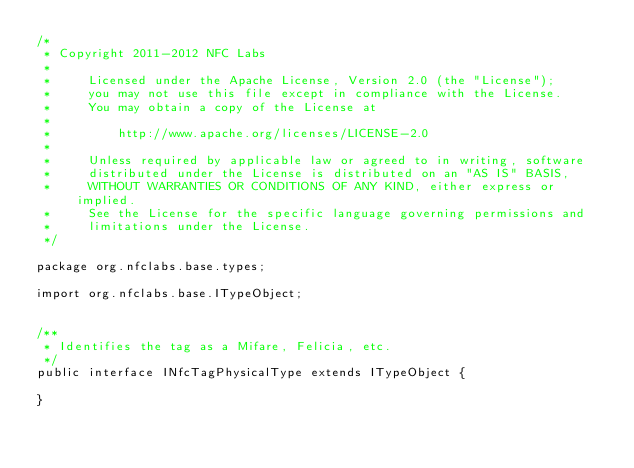Convert code to text. <code><loc_0><loc_0><loc_500><loc_500><_Java_>/*
 * Copyright 2011-2012 NFC Labs
 *
 *     Licensed under the Apache License, Version 2.0 (the "License");
 *     you may not use this file except in compliance with the License.
 *     You may obtain a copy of the License at
 *
 *         http://www.apache.org/licenses/LICENSE-2.0
 *
 *     Unless required by applicable law or agreed to in writing, software
 *     distributed under the License is distributed on an "AS IS" BASIS,
 *     WITHOUT WARRANTIES OR CONDITIONS OF ANY KIND, either express or implied.
 *     See the License for the specific language governing permissions and
 *     limitations under the License.
 */

package org.nfclabs.base.types;

import org.nfclabs.base.ITypeObject;


/**
 * Identifies the tag as a Mifare, Felicia, etc.
 */
public interface INfcTagPhysicalType extends ITypeObject {
 
}
 
</code> 